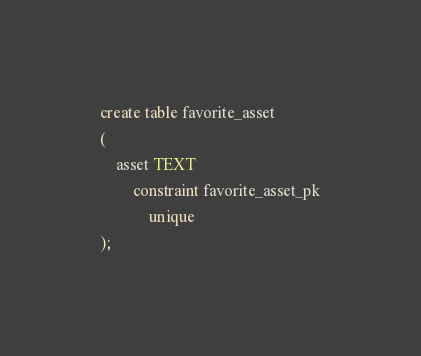<code> <loc_0><loc_0><loc_500><loc_500><_SQL_>create table favorite_asset
(
    asset TEXT
        constraint favorite_asset_pk
            unique
);

</code> 